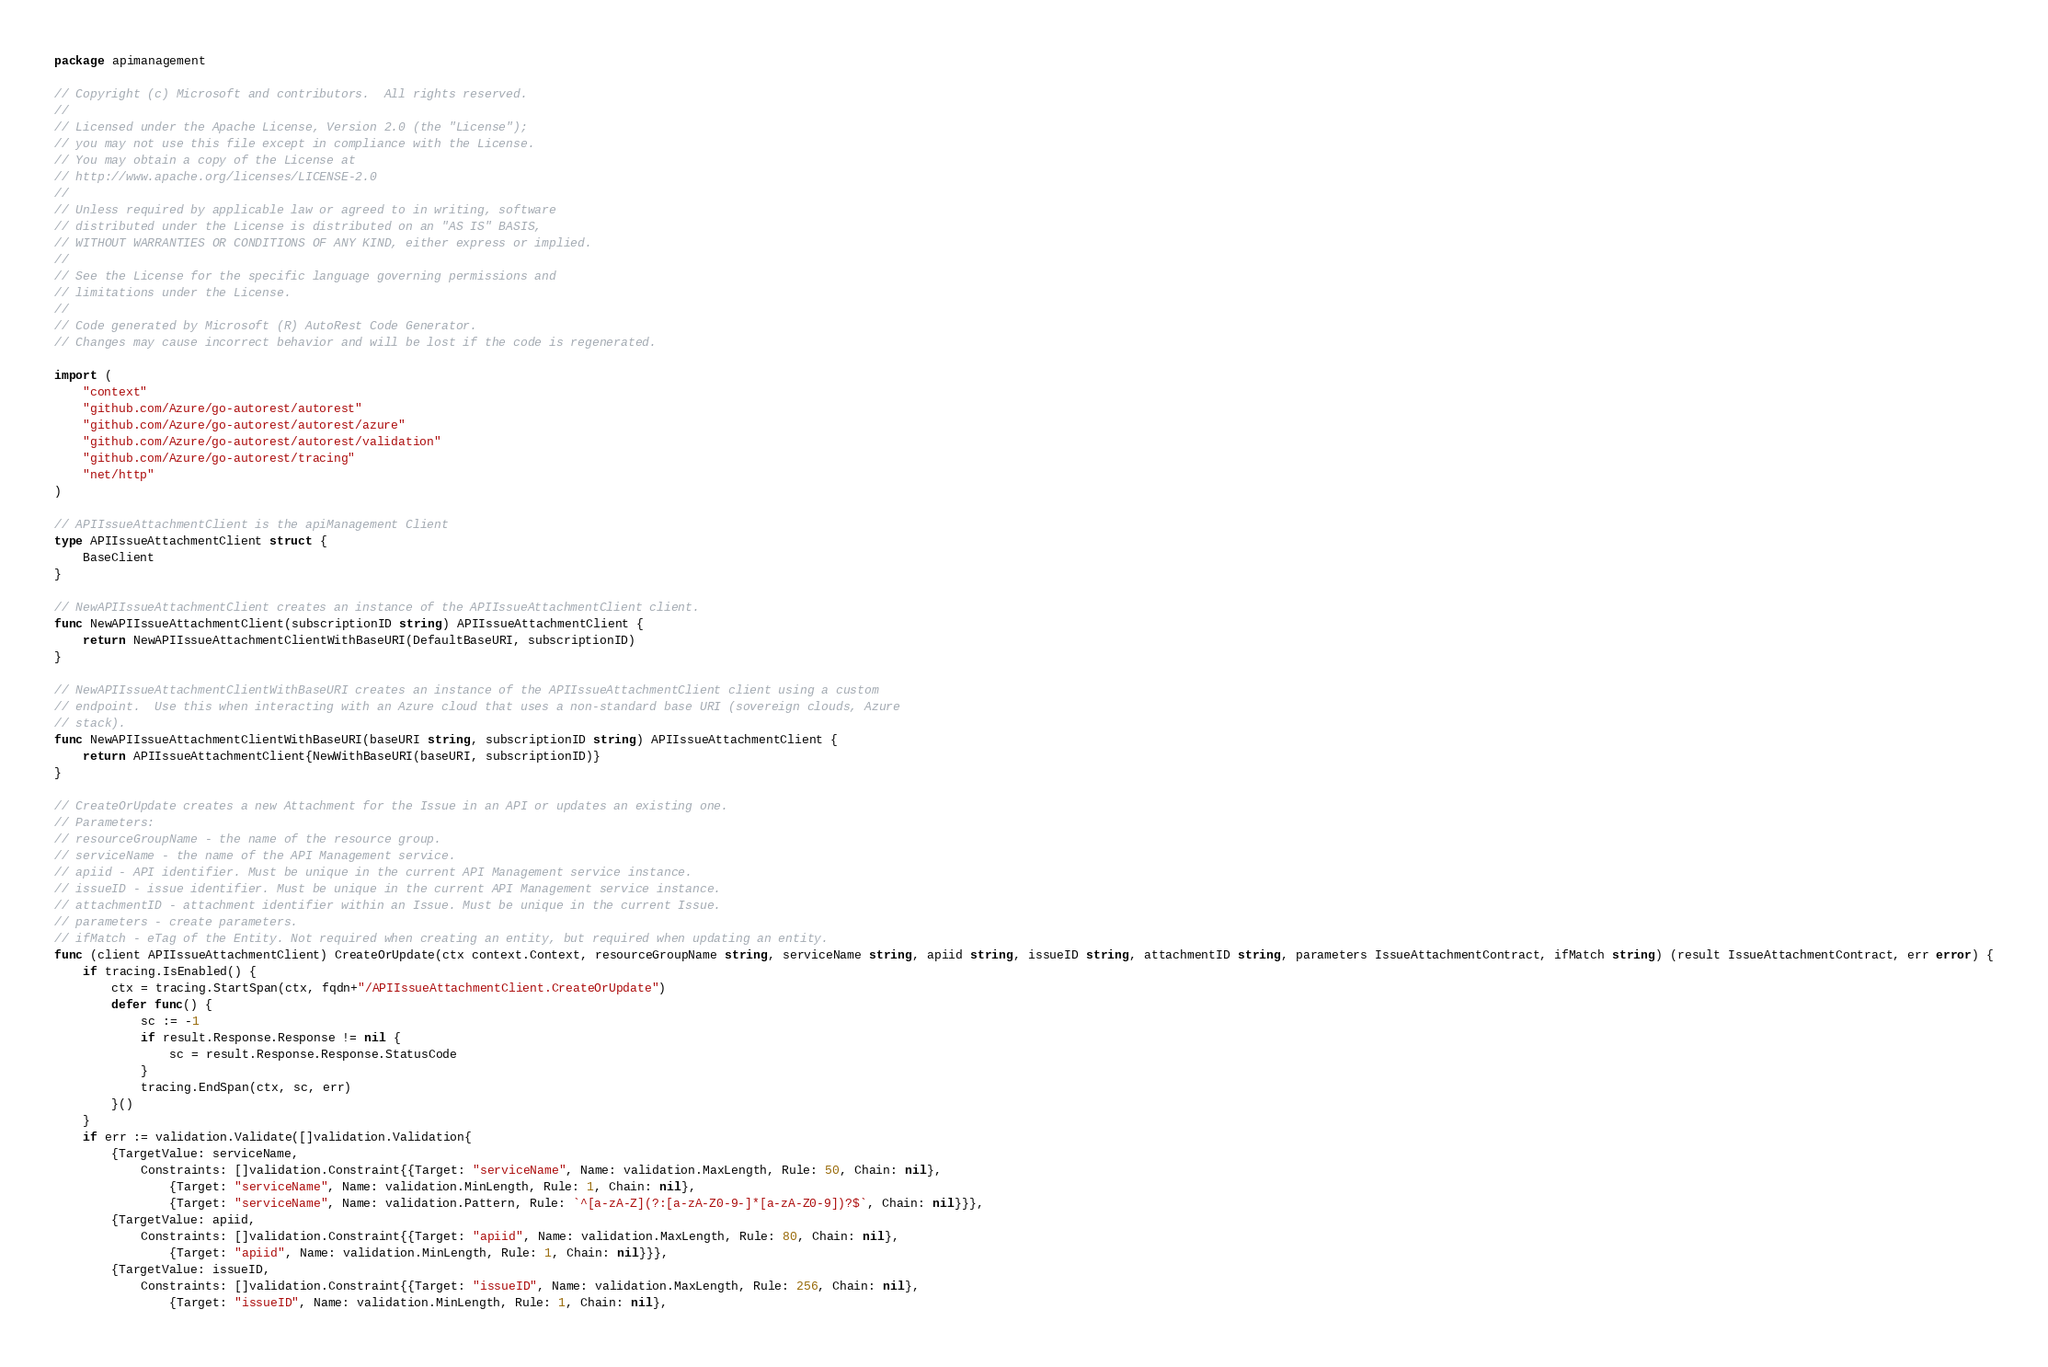<code> <loc_0><loc_0><loc_500><loc_500><_Go_>package apimanagement

// Copyright (c) Microsoft and contributors.  All rights reserved.
//
// Licensed under the Apache License, Version 2.0 (the "License");
// you may not use this file except in compliance with the License.
// You may obtain a copy of the License at
// http://www.apache.org/licenses/LICENSE-2.0
//
// Unless required by applicable law or agreed to in writing, software
// distributed under the License is distributed on an "AS IS" BASIS,
// WITHOUT WARRANTIES OR CONDITIONS OF ANY KIND, either express or implied.
//
// See the License for the specific language governing permissions and
// limitations under the License.
//
// Code generated by Microsoft (R) AutoRest Code Generator.
// Changes may cause incorrect behavior and will be lost if the code is regenerated.

import (
	"context"
	"github.com/Azure/go-autorest/autorest"
	"github.com/Azure/go-autorest/autorest/azure"
	"github.com/Azure/go-autorest/autorest/validation"
	"github.com/Azure/go-autorest/tracing"
	"net/http"
)

// APIIssueAttachmentClient is the apiManagement Client
type APIIssueAttachmentClient struct {
	BaseClient
}

// NewAPIIssueAttachmentClient creates an instance of the APIIssueAttachmentClient client.
func NewAPIIssueAttachmentClient(subscriptionID string) APIIssueAttachmentClient {
	return NewAPIIssueAttachmentClientWithBaseURI(DefaultBaseURI, subscriptionID)
}

// NewAPIIssueAttachmentClientWithBaseURI creates an instance of the APIIssueAttachmentClient client using a custom
// endpoint.  Use this when interacting with an Azure cloud that uses a non-standard base URI (sovereign clouds, Azure
// stack).
func NewAPIIssueAttachmentClientWithBaseURI(baseURI string, subscriptionID string) APIIssueAttachmentClient {
	return APIIssueAttachmentClient{NewWithBaseURI(baseURI, subscriptionID)}
}

// CreateOrUpdate creates a new Attachment for the Issue in an API or updates an existing one.
// Parameters:
// resourceGroupName - the name of the resource group.
// serviceName - the name of the API Management service.
// apiid - API identifier. Must be unique in the current API Management service instance.
// issueID - issue identifier. Must be unique in the current API Management service instance.
// attachmentID - attachment identifier within an Issue. Must be unique in the current Issue.
// parameters - create parameters.
// ifMatch - eTag of the Entity. Not required when creating an entity, but required when updating an entity.
func (client APIIssueAttachmentClient) CreateOrUpdate(ctx context.Context, resourceGroupName string, serviceName string, apiid string, issueID string, attachmentID string, parameters IssueAttachmentContract, ifMatch string) (result IssueAttachmentContract, err error) {
	if tracing.IsEnabled() {
		ctx = tracing.StartSpan(ctx, fqdn+"/APIIssueAttachmentClient.CreateOrUpdate")
		defer func() {
			sc := -1
			if result.Response.Response != nil {
				sc = result.Response.Response.StatusCode
			}
			tracing.EndSpan(ctx, sc, err)
		}()
	}
	if err := validation.Validate([]validation.Validation{
		{TargetValue: serviceName,
			Constraints: []validation.Constraint{{Target: "serviceName", Name: validation.MaxLength, Rule: 50, Chain: nil},
				{Target: "serviceName", Name: validation.MinLength, Rule: 1, Chain: nil},
				{Target: "serviceName", Name: validation.Pattern, Rule: `^[a-zA-Z](?:[a-zA-Z0-9-]*[a-zA-Z0-9])?$`, Chain: nil}}},
		{TargetValue: apiid,
			Constraints: []validation.Constraint{{Target: "apiid", Name: validation.MaxLength, Rule: 80, Chain: nil},
				{Target: "apiid", Name: validation.MinLength, Rule: 1, Chain: nil}}},
		{TargetValue: issueID,
			Constraints: []validation.Constraint{{Target: "issueID", Name: validation.MaxLength, Rule: 256, Chain: nil},
				{Target: "issueID", Name: validation.MinLength, Rule: 1, Chain: nil},</code> 